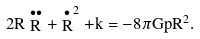<formula> <loc_0><loc_0><loc_500><loc_500>2 R \stackrel { \bullet \bullet } { R } + \stackrel { \bullet } { R } ^ { 2 } + k = - 8 \pi G p R ^ { 2 } .</formula> 